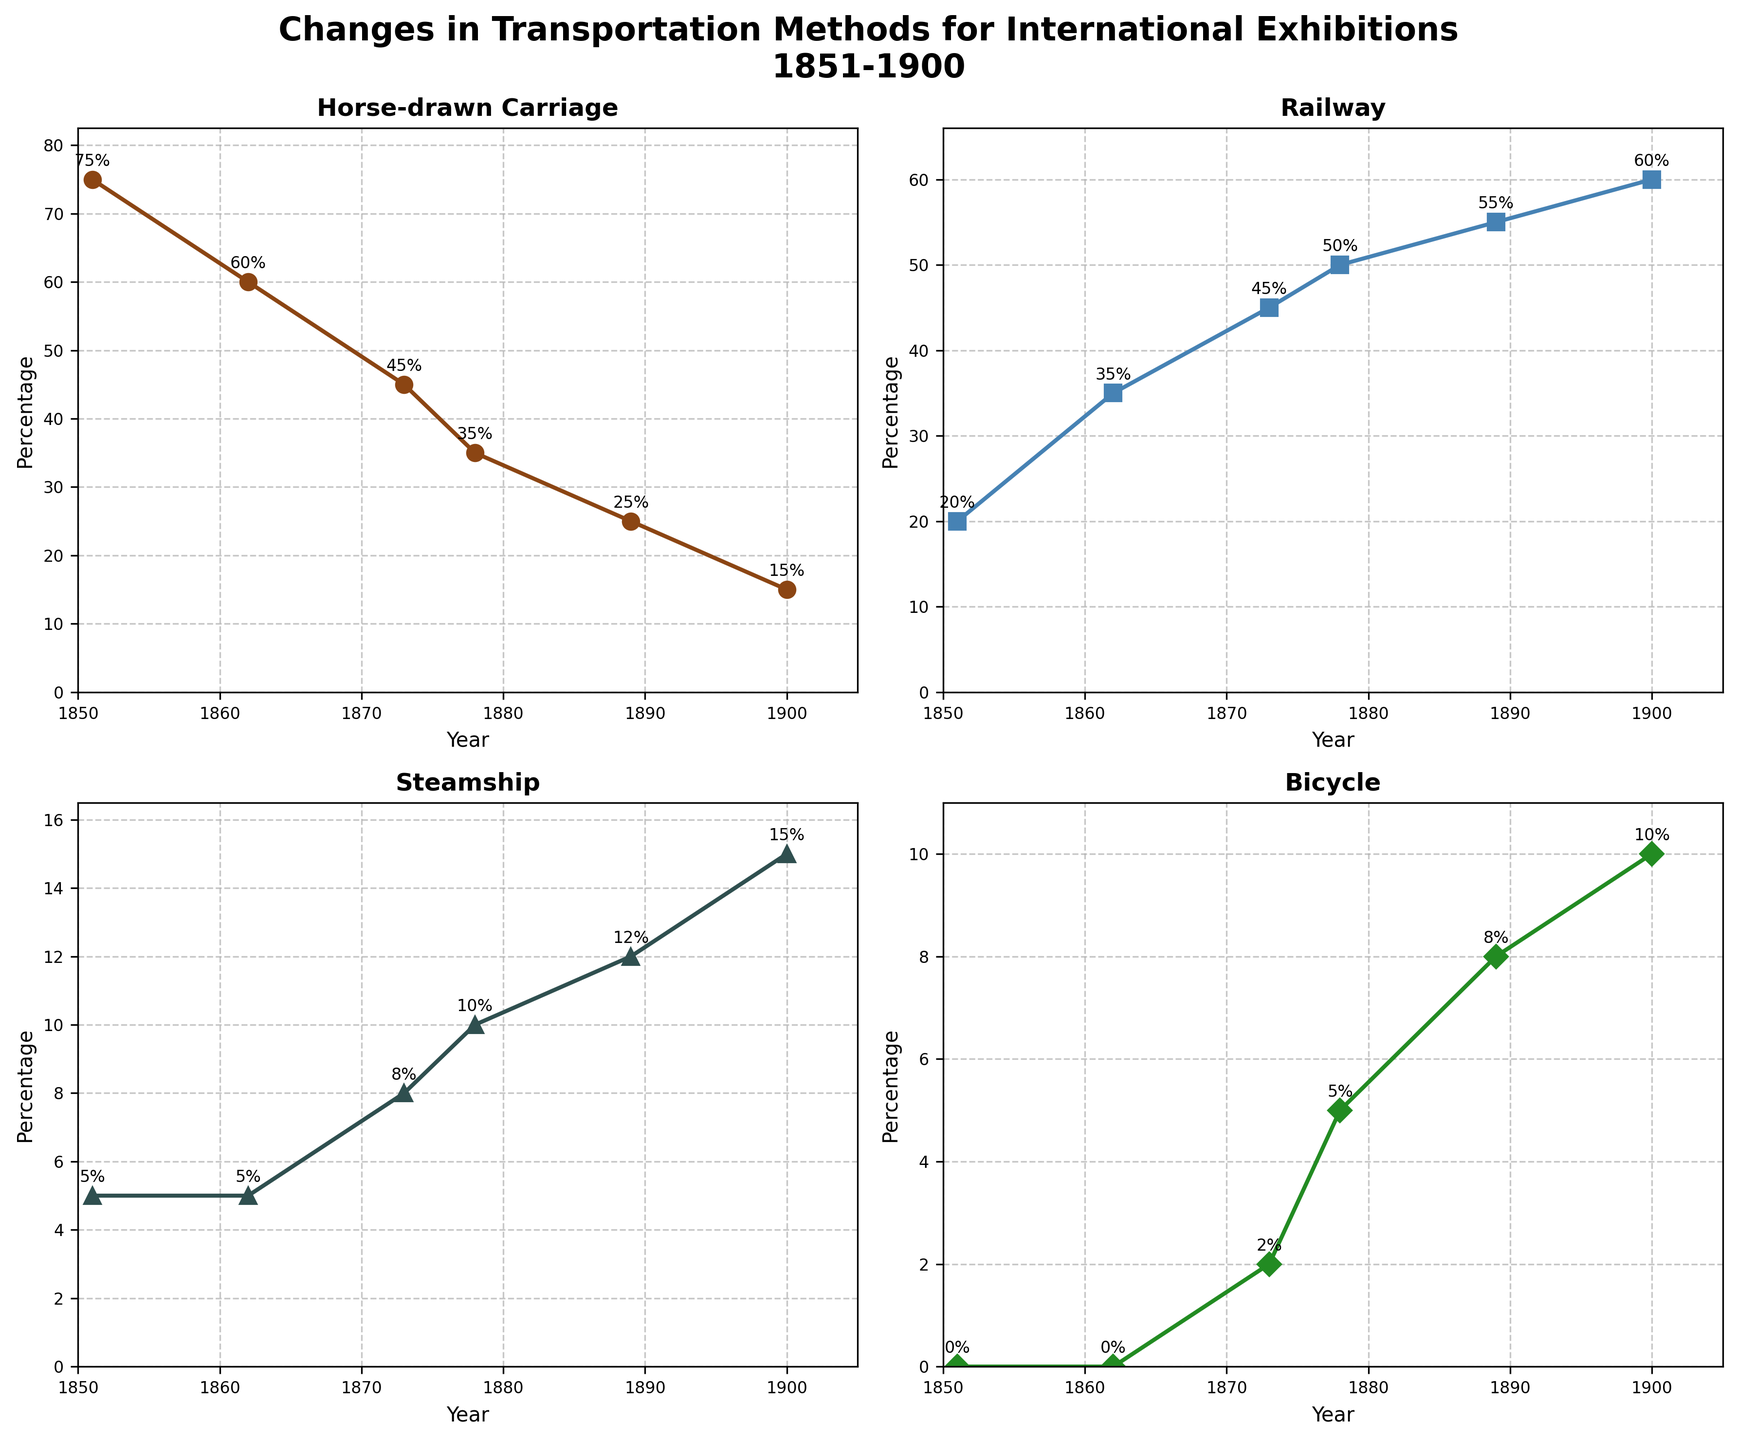What transportation method had the highest percentage in 1851? The figure shows a subplot for each transportation method across the years. Look at the plot for 1851 and identify the method with the highest percentage. In 1851, Horse-drawn Carriage had the highest percentage at 75%.
Answer: Horse-drawn Carriage By how many percentage points did the use of the railway increase from 1851 to 1900? Compare the percentage of railway use in 1851 and 1900. In 1851, it was 20%, and in 1900, it was 60%. The increase is 60% - 20% = 40%.
Answer: 40% Which transportation method showed a continuous increase from 1851 to 1900? Each plot line corresponds to a transportation method. The railway line consistently rises from 20% in 1851 to 60% in 1900, showing a continuous increase.
Answer: Railway What was the percentage of visitors using steamships in 1889? Look at the plot for steamships and find the percentage for the year 1889. It is 12%.
Answer: 12% Which transportation method had the least usage in 1851? Look at the plots for each transportation method in 1851. Steamship has the lowest value at 5%.
Answer: Steamship By how many percentage points did the use of horse-drawn carriages decrease from 1851 to 1900? Compare the percentage in 1851 and 1900 for horse-drawn carriages. In 1851, it was 75%, and in 1900, it was 15%. The decrease is 75% - 15% = 60%.
Answer: 60% What can be said about the use of bicycles from 1873 to 1900? Observe the plot for bicycles from 1873 onwards. In 1873, it begins at 2%, rises to 5% in 1878, 8% in 1889, and 10% by 1900. Thus, bicycle usage continually increased.
Answer: It increased Which transportation method had the most considerable increase percentage-wise between two consecutive exhibitions? Compare the increase in percentage between two consecutive data points for each transportation method. The railway increased from 35% to 45% between 1862 and 1873, a 10 percentage point difference, which is the largest among all methods in such intervals.
Answer: Railway What was the trend for steamship usage between 1862 and 1900? Observe the plot for steamships. Starting from 1862 at 5%, it rose to 8% in 1873, 10% in 1878, 12% in 1889, and 15% by 1900. Thus, there is a general upward trend.
Answer: Increasing 